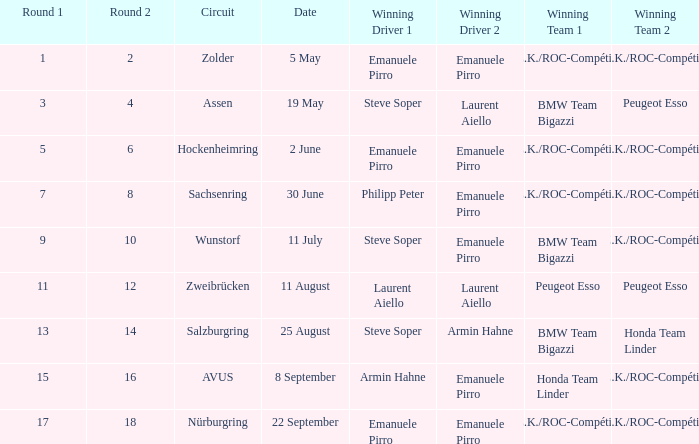What was the date when a.z.k./roc-compétition won the race at the zolder circuit? 5 May. 